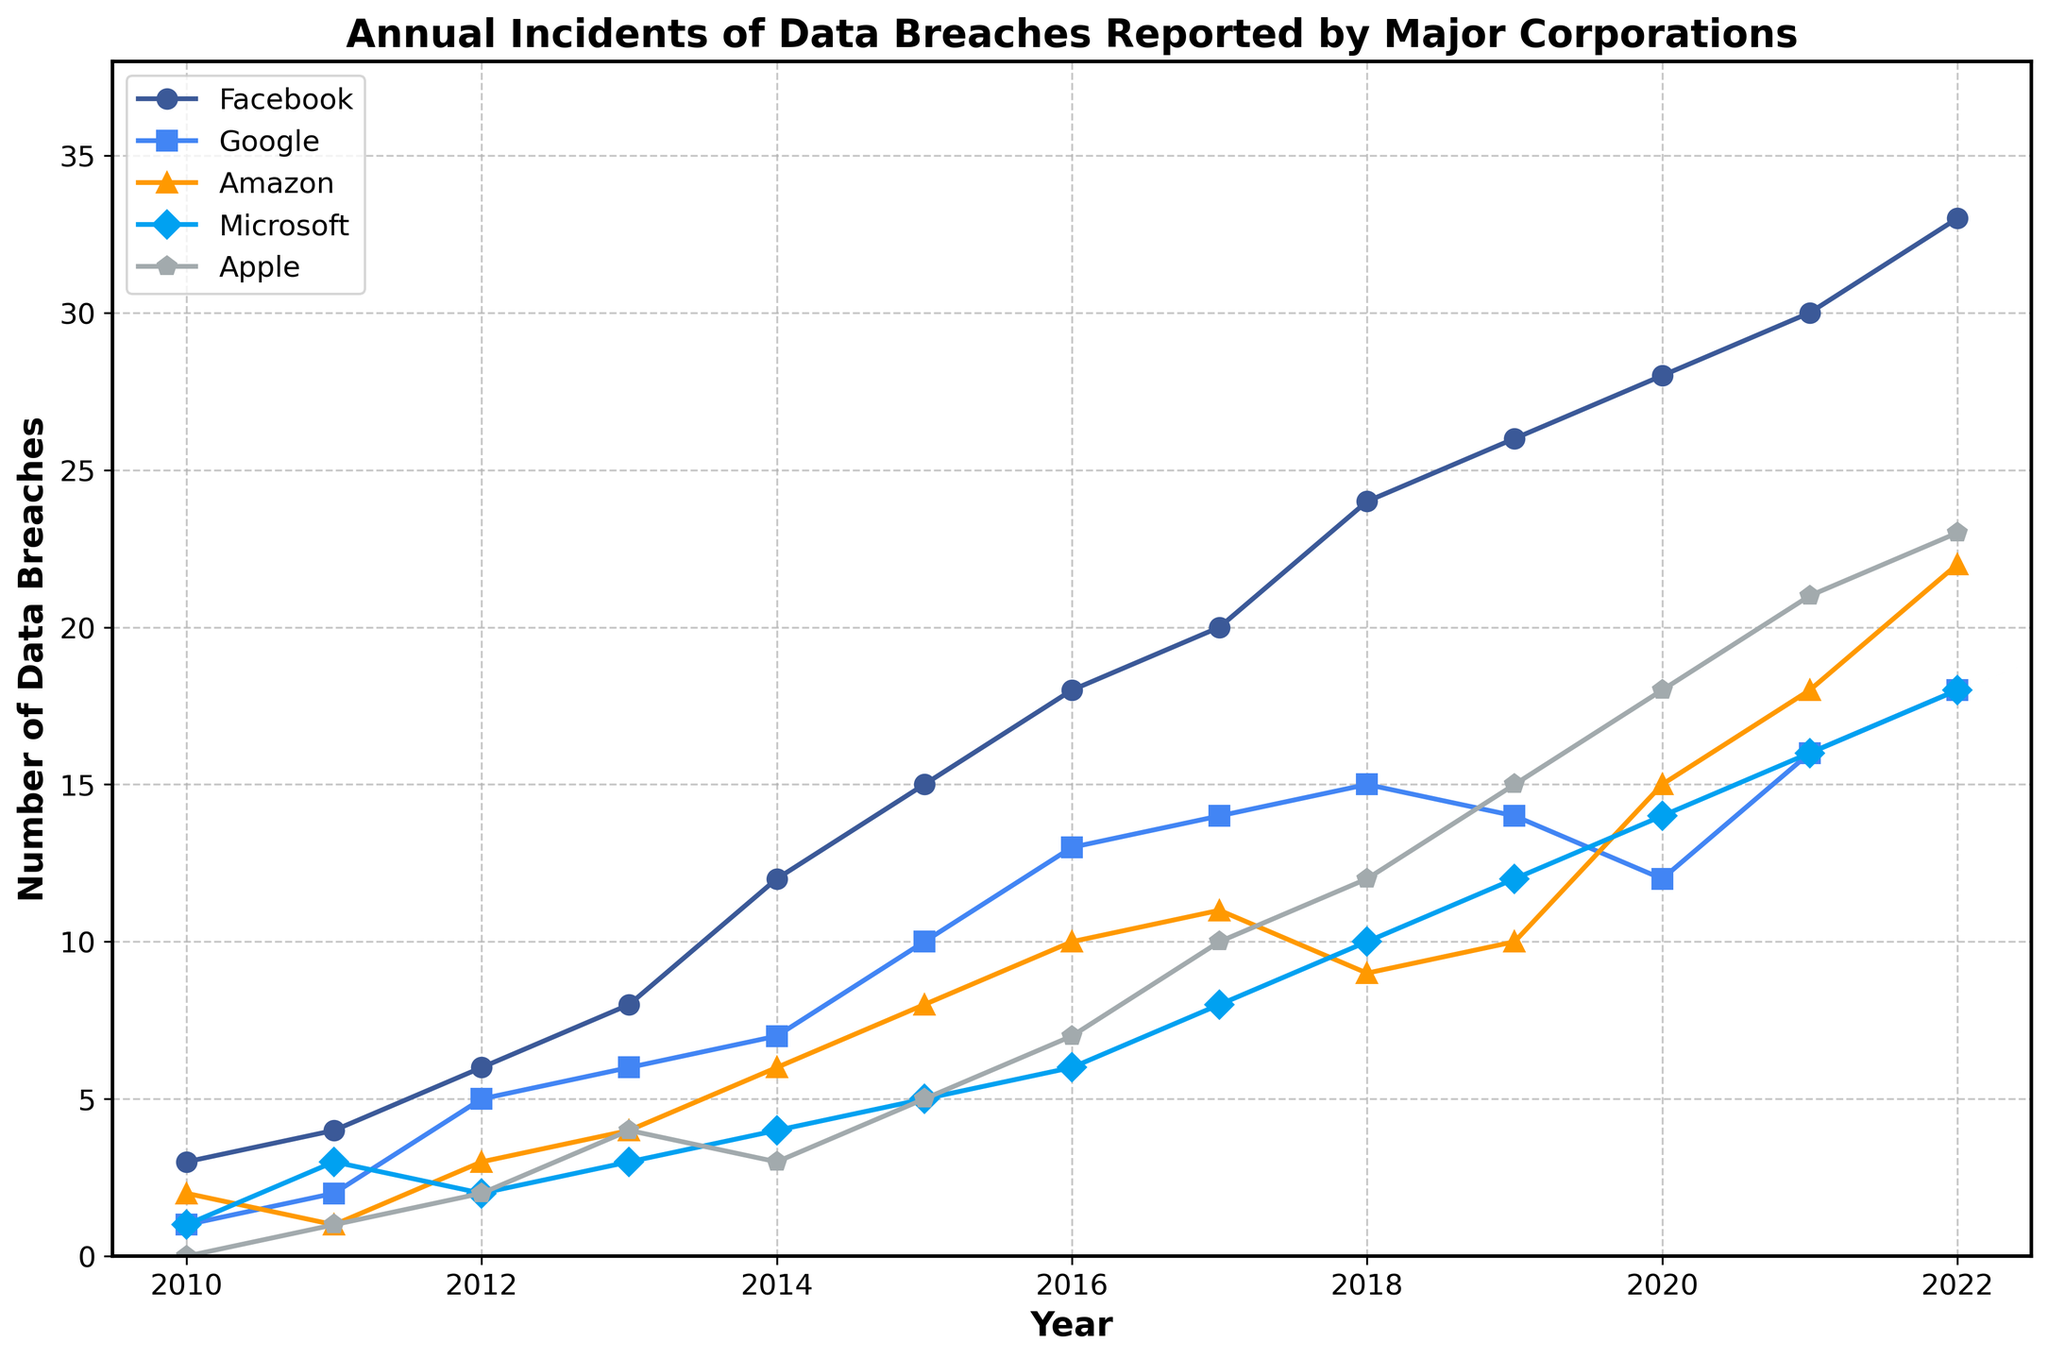What trend do you notice for Facebook data breaches from 2010 to 2022? Facebook's data breaches increase every year from 2010 to 2022, with no drops or plateaus.
Answer: Increasing trend Which company reported the highest number of data breaches in 2022? In 2022, the company with the highest number of data breaches is Facebook, with 33 reports.
Answer: Facebook How many incidents of data breaches did Google report in 2016 compared to 2018? In 2016, Google reported 13 data breaches, while in 2018, it reported 15. The number increased by 2 from 2016 to 2018.
Answer: Increased by 2 Which company had the most significant increase in data breaches from 2010 to 2022? By comparing the data from 2010 and 2022, Facebook had the most significant increase, going from 3 to 33 data breaches (an increase of 30 incidents).
Answer: Facebook What is the total number of data breaches reported by Apple over the period of 2010 to 2022? Sum the number of incidents for Apple from each year: 0 + 1 + 2 + 4 + 3 + 5 + 7 + 10 + 12 + 15 + 18 + 21 + 23 = 121.
Answer: 121 In which year did Amazon report the highest number of data breaches, and how many were reported? The highest number of breaches reported by Amazon was in 2022, with 22 incidents.
Answer: 2022, 22 incidents Which two companies had an equal number of reported data breaches in any year? In 2019, both Google and Amazon reported 14 data breaches each.
Answer: Google and Amazon in 2019 Was there any year where Microsoft's number of data breaches was more than Apple's? Yes, in 2010, Microsoft reported 1 incident while Apple reported none. Also in 2014, Microsoft reported 4 incidents, while Apple reported 3.
Answer: 2010 and 2014 Compare the total number of data breaches reported by Google and Amazon from 2010 to 2022. Which one is higher? Sum Google's incidents: 1 + 2 + 5 + 6 + 7 + 10 + 13 + 14 + 15 + 14 + 12 + 16 + 18 = 133. Sum Amazon's incidents: 2 + 1 + 3 + 4 + 6 + 8 + 10 + 11 + 9 + 10 + 15 + 18 + 22 = 119. Google reported 133 and Amazon reported 119. So, Google's total is higher.
Answer: Google During which years did Apple report fewer data breaches than the previous year? By tracking each year's data decreasing compared to the previous year, we find that Apple reported fewer data breaches in 2014 compared to 2013 (3 instead of 4) and in 2018 compared to 2017 (12 instead of 10).
Answer: 2014 and 2018 